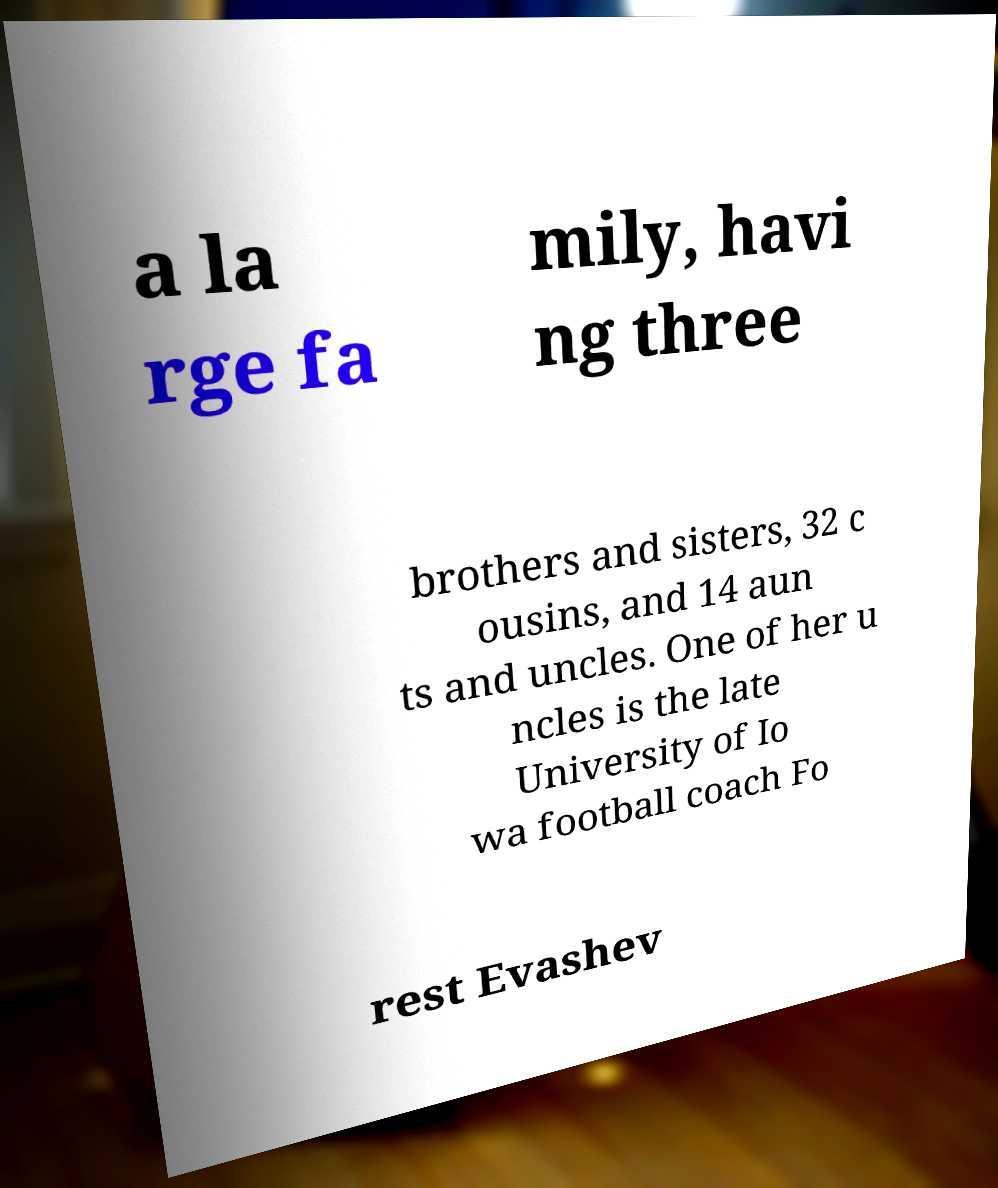Can you read and provide the text displayed in the image?This photo seems to have some interesting text. Can you extract and type it out for me? a la rge fa mily, havi ng three brothers and sisters, 32 c ousins, and 14 aun ts and uncles. One of her u ncles is the late University of Io wa football coach Fo rest Evashev 